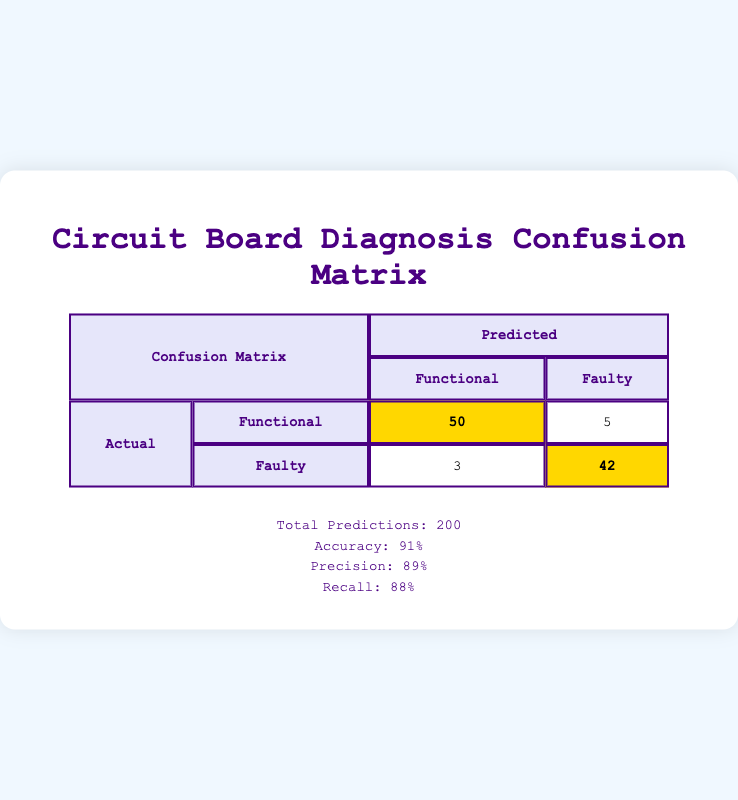What is the total number of predictions made? The "Total Predictions" value is directly provided in the summary section of the table. It states that the total number of predictions made is 200.
Answer: 200 How many true positives were identified as Functional? The true positives for the Functional category listed under the confusion matrix is 50, which means 50 functional circuit boards were correctly identified.
Answer: 50 What is the accuracy of the diagnosis tool? The accuracy value is provided in the summary section of the table, which indicates that the accuracy of the diagnosis tool in identifying faults is 91%.
Answer: 91% How many false negatives were there for the Faulty category? Referring to the false negatives section in the confusion matrix, it shows that there were 5 false negatives for the Faulty category, indicating that 5 faulty circuit boards were incorrectly identified as functional.
Answer: 5 Is it true that the precision of the diagnosis tool is above 90%? According to the summary section of the table, the precision is listed as 89%, which is below 90%. Therefore, the statement is false.
Answer: No What is the total number of true negatives? The total number of true negatives can be calculated by adding the true negatives of both categories. It states there are 50 true negatives for Functional and 42 for Faulty, giving a total of 50 + 42 = 92 true negatives.
Answer: 92 What is the recall for the Functional category? Recall is typically calculated as the number of true positives divided by the sum of true positives and false negatives. In this case, for the Functional category, recall is 50/(50 + 3), which equals 50/53 = approximately 0.9434 or 94.34%.
Answer: 94.34% How many predictions were incorrectly classified as Faulty? To find the total number of incorrect classifications as Faulty, add the false positives for Functional and the false negatives for Faulty. From the confusion matrix, we have 5 false positives (Functional) and 5 false negatives (Faulty), so 5 + 3 = 8 predictions were incorrectly classified as Faulty.
Answer: 8 What percentage of functional circuit boards were correctly classified? The percentage of correctly classified functional circuit boards can be calculated by dividing the true positives (Functional) by the total number of actual Functional (true positives + false negatives). Thus, the calculation is 50/(50 + 3) = 50/53 = approximately 94.34%.
Answer: 94.34% Which category had a higher rate of false positives, Functional or Faulty? The confusion matrix shows the false positives for Functional is 5 and for Faulty is 3. Comparing these values, Functional has a higher rate of false positives.
Answer: Functional 